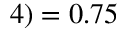Convert formula to latex. <formula><loc_0><loc_0><loc_500><loc_500>4 ) = 0 . 7 5</formula> 